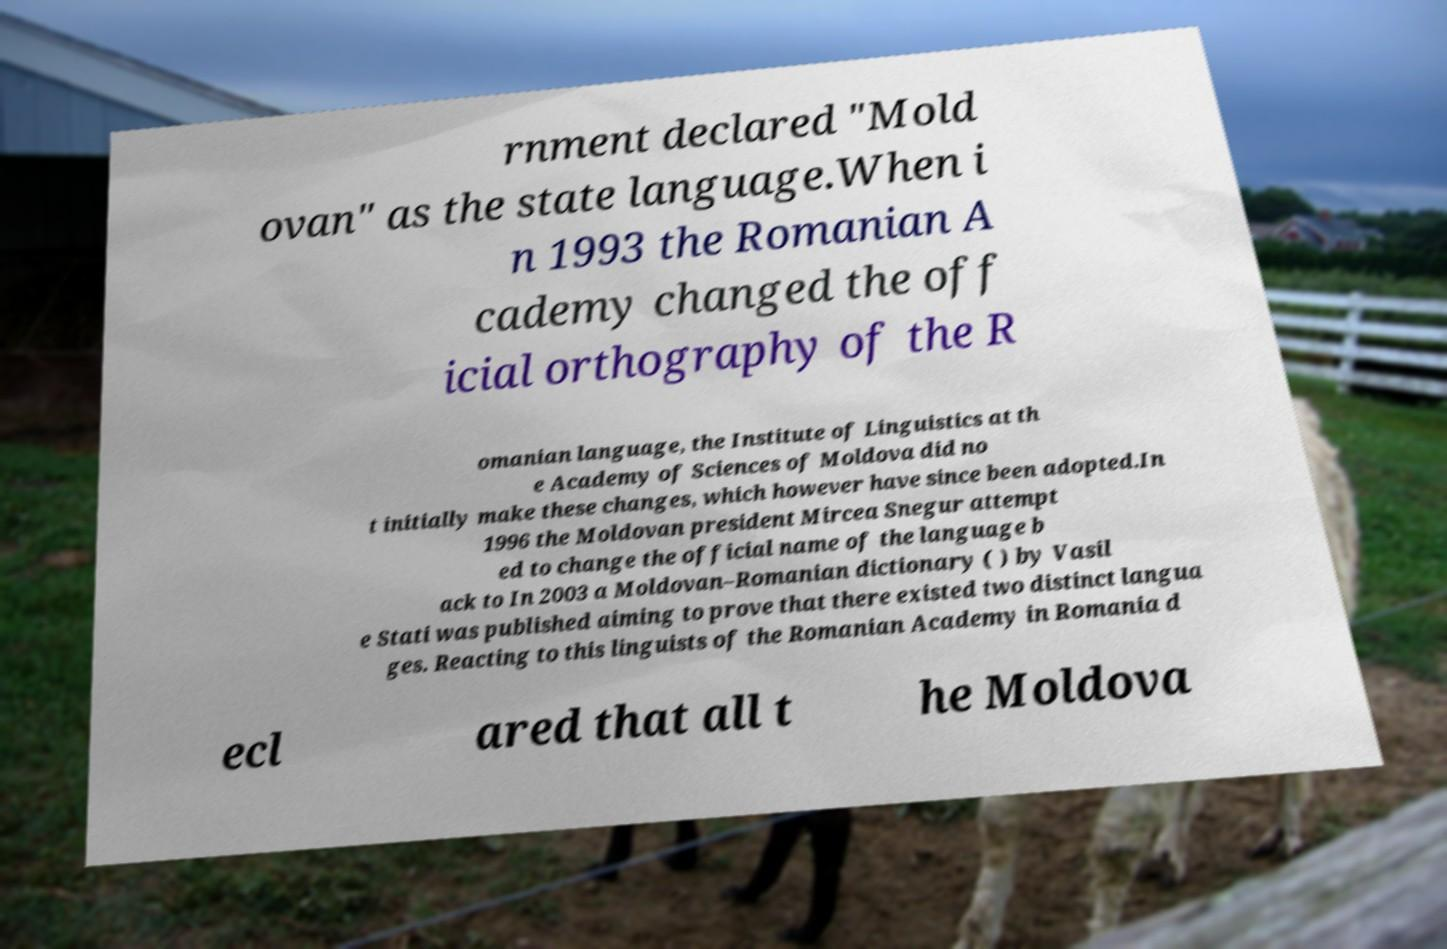Can you read and provide the text displayed in the image?This photo seems to have some interesting text. Can you extract and type it out for me? rnment declared "Mold ovan" as the state language.When i n 1993 the Romanian A cademy changed the off icial orthography of the R omanian language, the Institute of Linguistics at th e Academy of Sciences of Moldova did no t initially make these changes, which however have since been adopted.In 1996 the Moldovan president Mircea Snegur attempt ed to change the official name of the language b ack to In 2003 a Moldovan–Romanian dictionary ( ) by Vasil e Stati was published aiming to prove that there existed two distinct langua ges. Reacting to this linguists of the Romanian Academy in Romania d ecl ared that all t he Moldova 